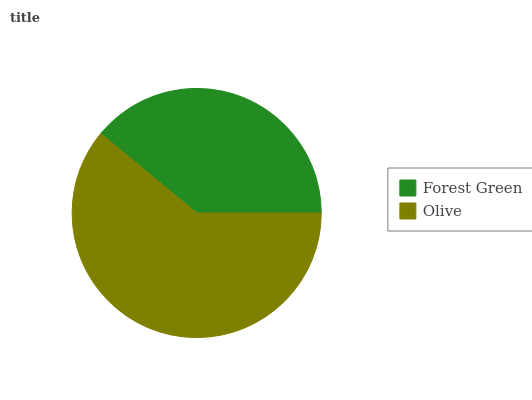Is Forest Green the minimum?
Answer yes or no. Yes. Is Olive the maximum?
Answer yes or no. Yes. Is Olive the minimum?
Answer yes or no. No. Is Olive greater than Forest Green?
Answer yes or no. Yes. Is Forest Green less than Olive?
Answer yes or no. Yes. Is Forest Green greater than Olive?
Answer yes or no. No. Is Olive less than Forest Green?
Answer yes or no. No. Is Olive the high median?
Answer yes or no. Yes. Is Forest Green the low median?
Answer yes or no. Yes. Is Forest Green the high median?
Answer yes or no. No. Is Olive the low median?
Answer yes or no. No. 